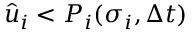Convert formula to latex. <formula><loc_0><loc_0><loc_500><loc_500>\hat { u } _ { i } < P _ { i } ( \sigma _ { i } , \Delta t )</formula> 